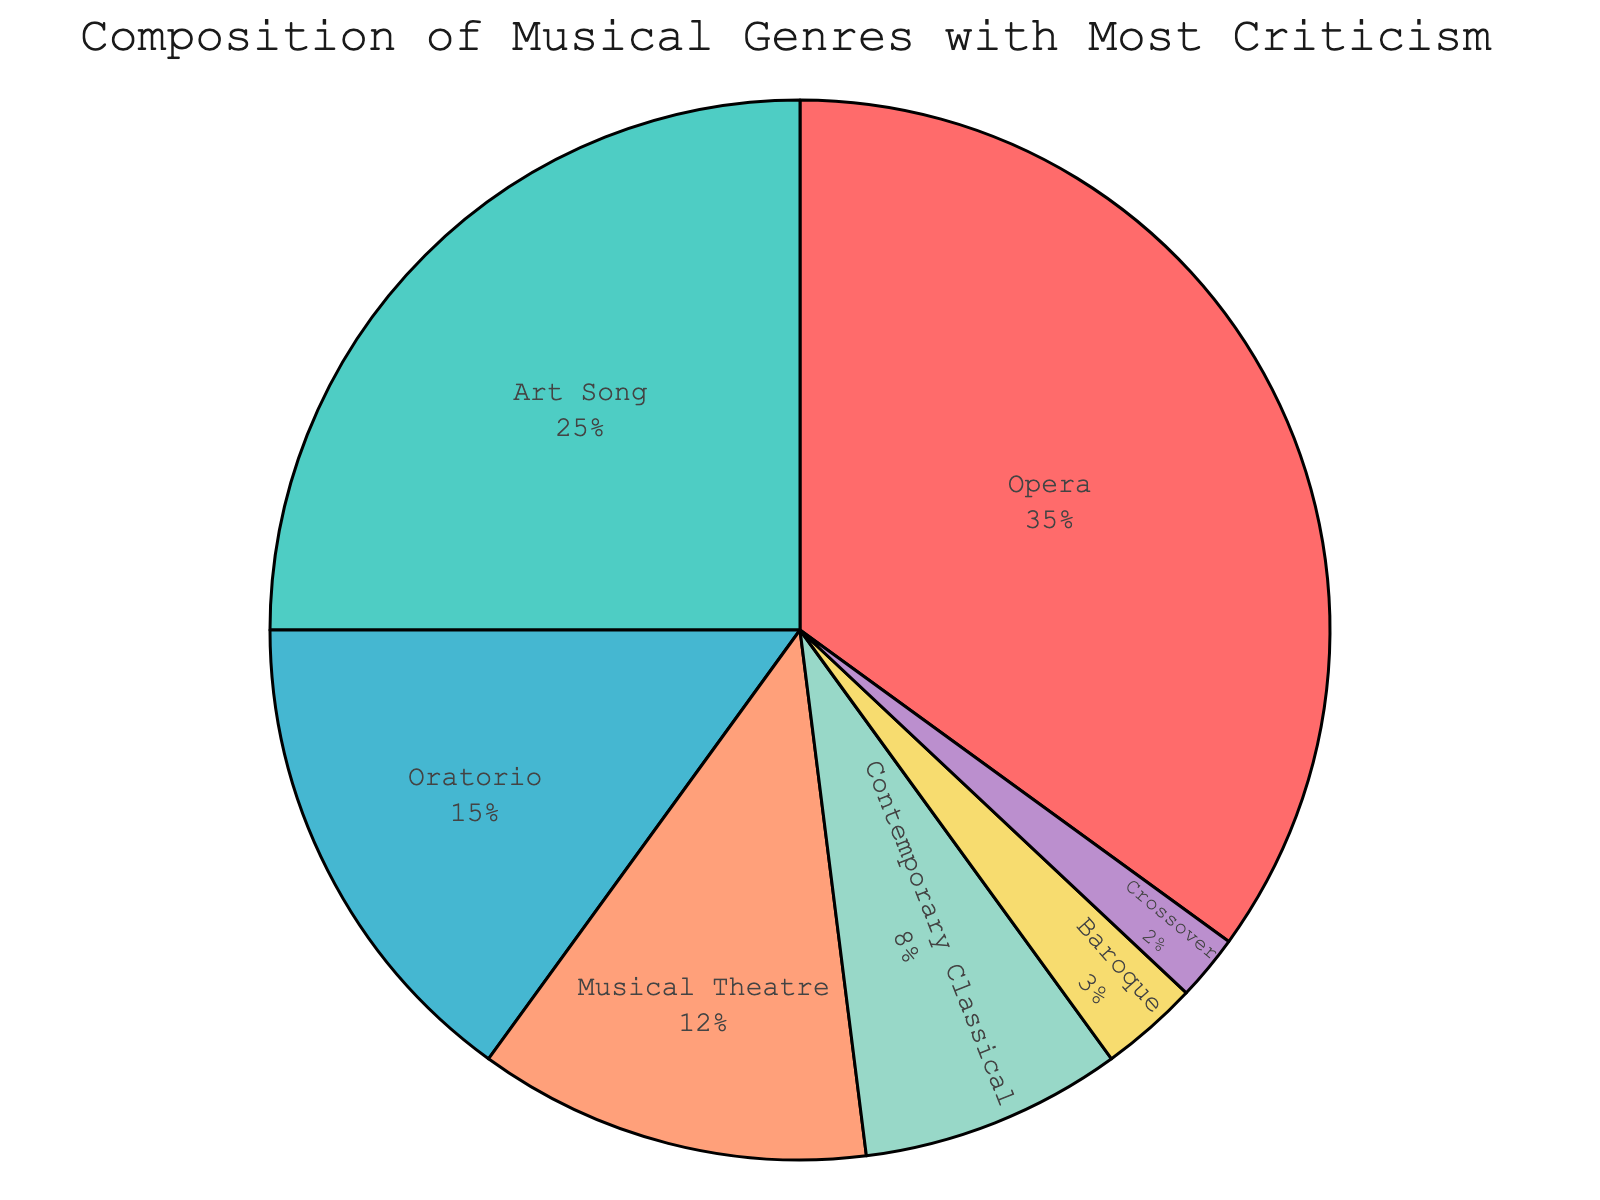What genre received the least criticism for the soprano's performances? The "Crossover" genre had the smallest percentage of criticism at 2%.
Answer: Crossover What percentage of criticism did Opera and Art Song genres receive combined? Combine the percentages of Opera and Art Song: 35%+25%.
Answer: 60% Which genre received twice as much criticism as Contemporary Classical? Contemporary Classical received 8% criticism. The genre with 2 times this percentage is Art Song with 25%.
Answer: Art Song How much higher is the percentage of criticism in Opera compared to Baroque? Opera has 35% criticism, and Baroque has 3%. The difference is calculated by 35% - 3%.
Answer: 32% Compare the criticism percentages of Musical Theatre and Oratorio. Which one received more criticism, and by how much? Musical Theatre has 12% and Oratorio has 15%. The difference is 15% - 12%. Oratorio received more criticism.
Answer: Oratorio, by 3% What is the visual significance of the dark red section in the pie chart? The dark red section represents the "Opera" genre which has the largest slice, indicating it received the most criticism at 35%.
Answer: Opera, largest slice From the data, what percentage did genres other than Opera and Art Song receive combined? Deduct percentages of Opera (35%) and Art Song (25%) from 100%. Calculate 100% - (35% + 25%).
Answer: 40% Calculate the difference in percentage between the total criticism of Baroque and Crossover genres and the total criticism of Opera and Contemporary Classical genres combined. Sum Baroque (3%) and Crossover (2%) which equals 5%. Sum Opera (35%) and Contemporary Classical (8%) which equals 43%. The difference is 43% - 5%.
Answer: 38% 